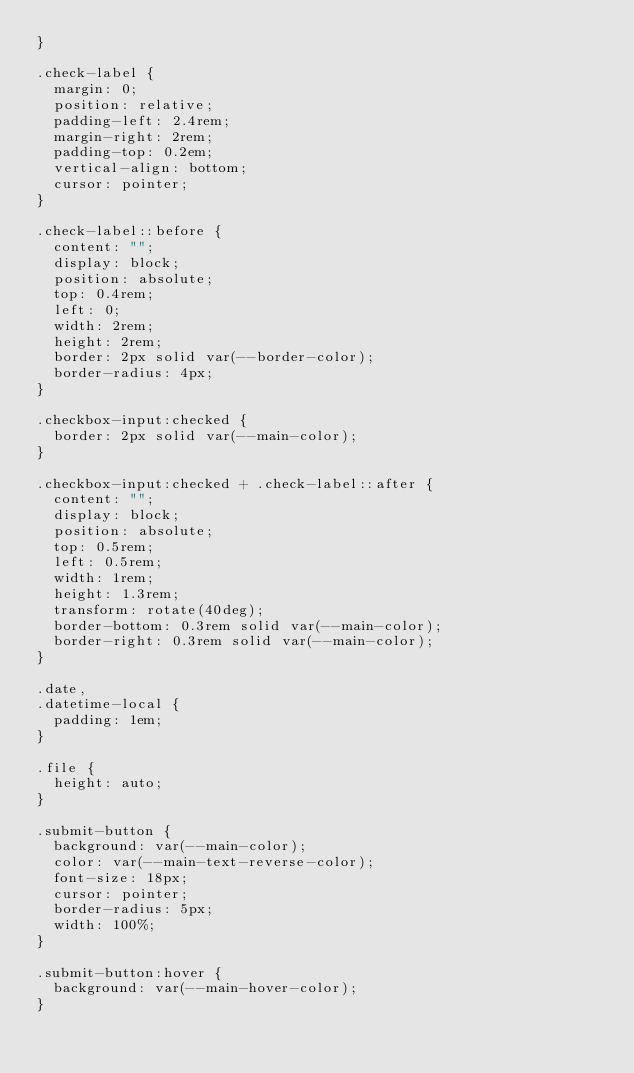<code> <loc_0><loc_0><loc_500><loc_500><_CSS_>}

.check-label {
  margin: 0;
  position: relative;
  padding-left: 2.4rem;
  margin-right: 2rem;
  padding-top: 0.2em;
  vertical-align: bottom;
  cursor: pointer;
}

.check-label::before {
  content: "";
  display: block;
  position: absolute;
  top: 0.4rem;
  left: 0;
  width: 2rem;
  height: 2rem;
  border: 2px solid var(--border-color);
  border-radius: 4px;
}

.checkbox-input:checked {
  border: 2px solid var(--main-color);
}

.checkbox-input:checked + .check-label::after {
  content: "";
  display: block;
  position: absolute;
  top: 0.5rem;
  left: 0.5rem;
  width: 1rem;
  height: 1.3rem;
  transform: rotate(40deg);
  border-bottom: 0.3rem solid var(--main-color);
  border-right: 0.3rem solid var(--main-color);
}

.date,
.datetime-local {
  padding: 1em;
}

.file {
  height: auto;
}

.submit-button {
  background: var(--main-color);
  color: var(--main-text-reverse-color);
  font-size: 18px;
  cursor: pointer;
  border-radius: 5px;
  width: 100%;
}

.submit-button:hover {
  background: var(--main-hover-color);
}
</code> 